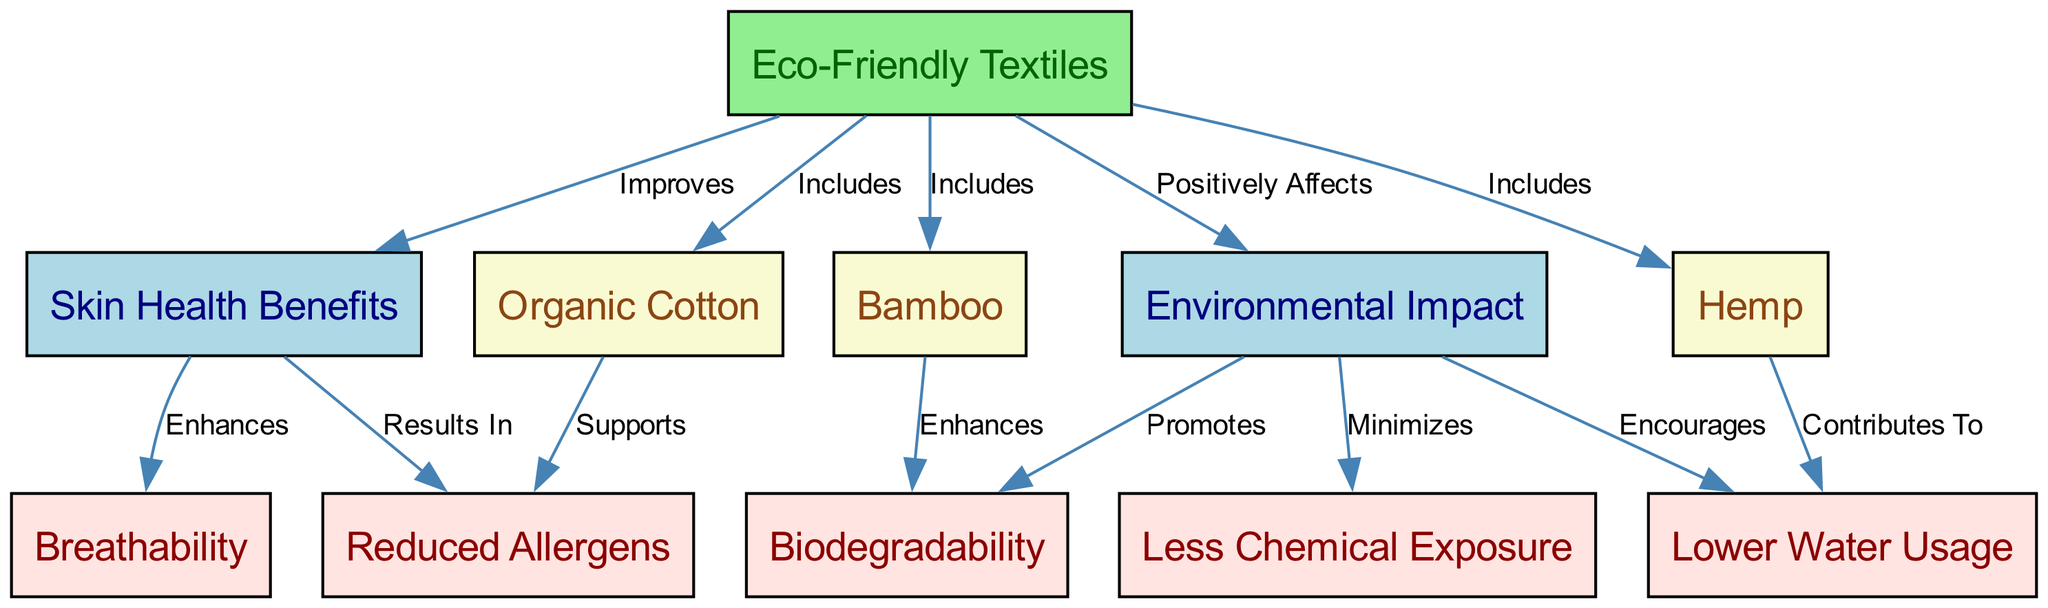What is the central theme of the diagram? The diagram centers around "Eco-Friendly Textiles," which is the primary node that connects various benefits related to skin health and environmental impact.
Answer: Eco-Friendly Textiles How many types of eco-friendly textiles are included in the diagram? There are three types of eco-friendly textiles mentioned: Organic Cotton, Hemp, and Bamboo, indicated by the connections from the central node to these textile types.
Answer: Three What benefit of eco-friendly textiles results in reduced allergens? The benefit highlighted is "Reduced Allergens," which is a direct outcome of using eco-friendly textiles, specifically under the "Skin Health Benefits."
Answer: Reduced Allergens Which eco-friendly textile contributes to lower water usage? The eco-friendly textile indicated to contribute to lower water usage is "Hemp," which has a direct connection to the environmental impact aspect.
Answer: Hemp What relationship connects eco-friendly textiles and skin health benefits? The relationship is described as "Improves" between "Eco-Friendly Textiles" and "Skin Health Benefits," showing that the former enhances the latter.
Answer: Improves How does bamboo impact biodegradability? Bamboo enhances biodegradability, as shown by its direct linkage to the environmental impact section, promoting this benefit.
Answer: Enhances What are the main categories represented in the diagram? The main categories in the diagram are "Skin Health Benefits" and "Environmental Impact," both stemming from the central theme of eco-friendly textiles.
Answer: Skin Health Benefits and Environmental Impact What is minimized due to eco-friendly textiles according to the diagram? The diagram states that eco-friendly textiles minimize "Less Chemical Exposure," which is an important aspect of health and safety.
Answer: Less Chemical Exposure Which eco-friendly textile supports breathability? "Organic Cotton" supports breathability, as indicated by its relationship in the skin health benefits section, showing a beneficial aspect of this textile.
Answer: Organic Cotton 